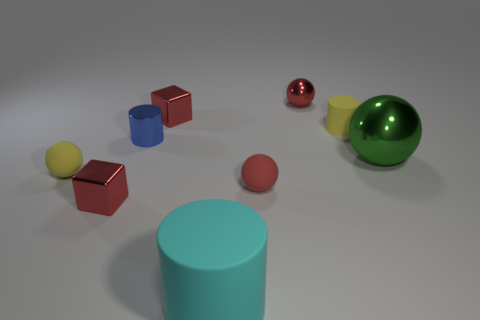How many other objects are there of the same material as the large green ball?
Your answer should be very brief. 4. What is the big thing that is on the right side of the red metal thing to the right of the tiny block that is behind the blue metallic cylinder made of?
Ensure brevity in your answer.  Metal. Are the blue thing and the yellow sphere made of the same material?
Offer a very short reply. No. What number of balls are either large cyan matte objects or red metal things?
Ensure brevity in your answer.  1. What is the color of the tiny metallic cube in front of the yellow matte cylinder?
Ensure brevity in your answer.  Red. What number of matte objects are either blue blocks or cubes?
Your response must be concise. 0. There is a tiny yellow thing that is in front of the large object on the right side of the cyan cylinder; what is it made of?
Your response must be concise. Rubber. There is a ball that is the same color as the tiny rubber cylinder; what is it made of?
Make the answer very short. Rubber. What is the color of the big matte object?
Your answer should be very brief. Cyan. Are there any big cyan matte objects that are behind the small shiny thing that is in front of the large green metallic sphere?
Your answer should be compact. No. 